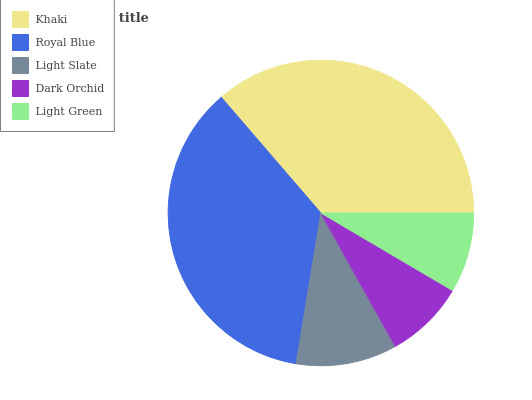Is Dark Orchid the minimum?
Answer yes or no. Yes. Is Khaki the maximum?
Answer yes or no. Yes. Is Royal Blue the minimum?
Answer yes or no. No. Is Royal Blue the maximum?
Answer yes or no. No. Is Khaki greater than Royal Blue?
Answer yes or no. Yes. Is Royal Blue less than Khaki?
Answer yes or no. Yes. Is Royal Blue greater than Khaki?
Answer yes or no. No. Is Khaki less than Royal Blue?
Answer yes or no. No. Is Light Slate the high median?
Answer yes or no. Yes. Is Light Slate the low median?
Answer yes or no. Yes. Is Light Green the high median?
Answer yes or no. No. Is Light Green the low median?
Answer yes or no. No. 